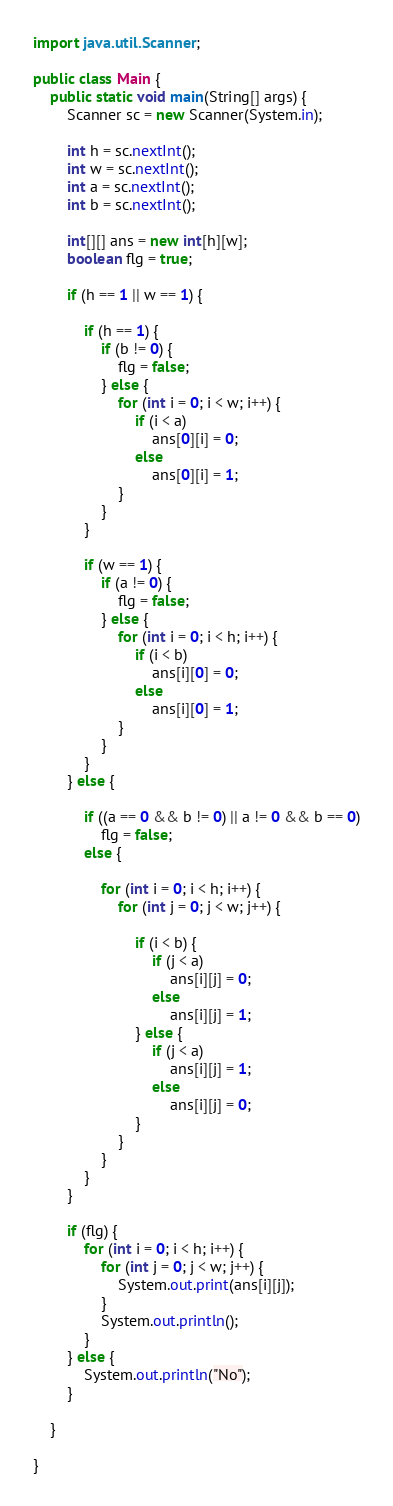Convert code to text. <code><loc_0><loc_0><loc_500><loc_500><_Java_>

import java.util.Scanner;

public class Main {
	public static void main(String[] args) {
		Scanner sc = new Scanner(System.in);

		int h = sc.nextInt();
		int w = sc.nextInt();
		int a = sc.nextInt();
		int b = sc.nextInt();

		int[][] ans = new int[h][w];
		boolean flg = true;

		if (h == 1 || w == 1) {

			if (h == 1) {
				if (b != 0) {
					flg = false;
				} else {
					for (int i = 0; i < w; i++) {
						if (i < a)
							ans[0][i] = 0;
						else
							ans[0][i] = 1;
					}
				}
			}

			if (w == 1) {
				if (a != 0) {
					flg = false;
				} else {
					for (int i = 0; i < h; i++) {
						if (i < b)
							ans[i][0] = 0;
						else
							ans[i][0] = 1;
					}
				}
			}
		} else {

			if ((a == 0 && b != 0) || a != 0 && b == 0)
				flg = false;
			else {

				for (int i = 0; i < h; i++) {
					for (int j = 0; j < w; j++) {

						if (i < b) {
							if (j < a)
								ans[i][j] = 0;
							else
								ans[i][j] = 1;
						} else {
							if (j < a)
								ans[i][j] = 1;
							else
								ans[i][j] = 0;
						}
					}
				}
			}
		}

		if (flg) {
			for (int i = 0; i < h; i++) {
				for (int j = 0; j < w; j++) {
					System.out.print(ans[i][j]);
				}
				System.out.println();
			}
		} else {
			System.out.println("No");
		}

	}

}
</code> 